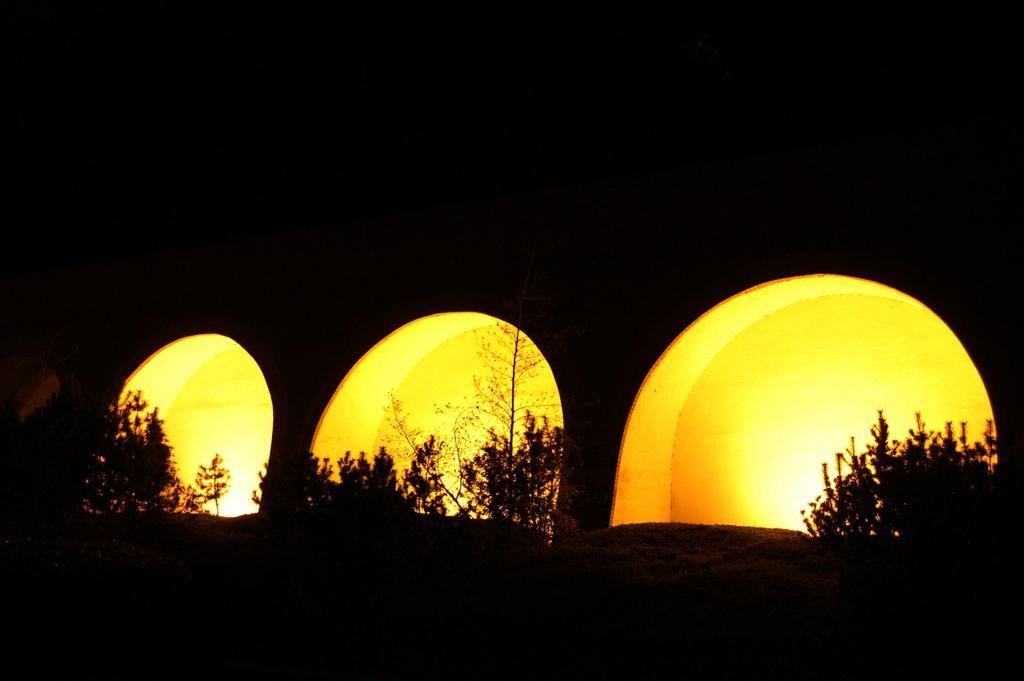Describe this image in one or two sentences. In this picture we can see lights on the wall, beside that we can see the plants. At the top there is a darkness. 